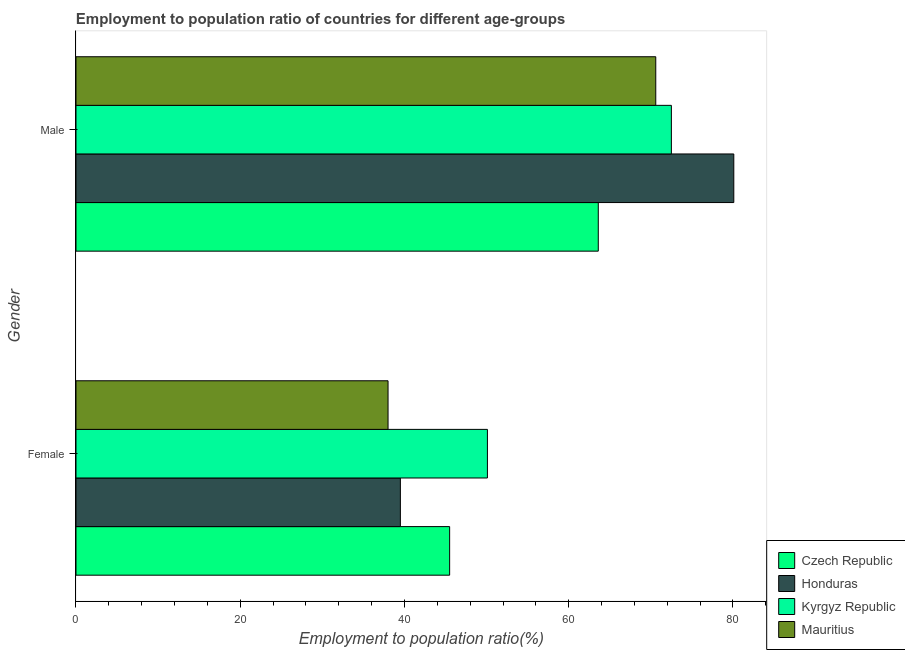Are the number of bars on each tick of the Y-axis equal?
Give a very brief answer. Yes. How many bars are there on the 2nd tick from the bottom?
Make the answer very short. 4. What is the label of the 1st group of bars from the top?
Keep it short and to the point. Male. What is the employment to population ratio(female) in Mauritius?
Ensure brevity in your answer.  38. Across all countries, what is the maximum employment to population ratio(female)?
Provide a short and direct response. 50.1. In which country was the employment to population ratio(male) maximum?
Keep it short and to the point. Honduras. In which country was the employment to population ratio(female) minimum?
Give a very brief answer. Mauritius. What is the total employment to population ratio(female) in the graph?
Ensure brevity in your answer.  173.1. What is the difference between the employment to population ratio(male) in Mauritius and that in Honduras?
Your response must be concise. -9.5. What is the difference between the employment to population ratio(female) in Czech Republic and the employment to population ratio(male) in Mauritius?
Your answer should be very brief. -25.1. What is the average employment to population ratio(female) per country?
Your answer should be compact. 43.27. What is the difference between the employment to population ratio(female) and employment to population ratio(male) in Czech Republic?
Provide a succinct answer. -18.1. In how many countries, is the employment to population ratio(male) greater than 68 %?
Keep it short and to the point. 3. What is the ratio of the employment to population ratio(female) in Czech Republic to that in Kyrgyz Republic?
Keep it short and to the point. 0.91. In how many countries, is the employment to population ratio(female) greater than the average employment to population ratio(female) taken over all countries?
Your answer should be very brief. 2. What does the 2nd bar from the top in Male represents?
Offer a terse response. Kyrgyz Republic. What does the 4th bar from the bottom in Female represents?
Your answer should be compact. Mauritius. How many countries are there in the graph?
Offer a very short reply. 4. What is the title of the graph?
Ensure brevity in your answer.  Employment to population ratio of countries for different age-groups. Does "Equatorial Guinea" appear as one of the legend labels in the graph?
Provide a short and direct response. No. What is the Employment to population ratio(%) in Czech Republic in Female?
Ensure brevity in your answer.  45.5. What is the Employment to population ratio(%) of Honduras in Female?
Provide a succinct answer. 39.5. What is the Employment to population ratio(%) in Kyrgyz Republic in Female?
Provide a short and direct response. 50.1. What is the Employment to population ratio(%) of Mauritius in Female?
Provide a short and direct response. 38. What is the Employment to population ratio(%) in Czech Republic in Male?
Provide a succinct answer. 63.6. What is the Employment to population ratio(%) of Honduras in Male?
Your answer should be compact. 80.1. What is the Employment to population ratio(%) in Kyrgyz Republic in Male?
Give a very brief answer. 72.5. What is the Employment to population ratio(%) in Mauritius in Male?
Keep it short and to the point. 70.6. Across all Gender, what is the maximum Employment to population ratio(%) of Czech Republic?
Keep it short and to the point. 63.6. Across all Gender, what is the maximum Employment to population ratio(%) of Honduras?
Provide a short and direct response. 80.1. Across all Gender, what is the maximum Employment to population ratio(%) in Kyrgyz Republic?
Offer a terse response. 72.5. Across all Gender, what is the maximum Employment to population ratio(%) in Mauritius?
Your response must be concise. 70.6. Across all Gender, what is the minimum Employment to population ratio(%) in Czech Republic?
Keep it short and to the point. 45.5. Across all Gender, what is the minimum Employment to population ratio(%) of Honduras?
Give a very brief answer. 39.5. Across all Gender, what is the minimum Employment to population ratio(%) of Kyrgyz Republic?
Your response must be concise. 50.1. What is the total Employment to population ratio(%) in Czech Republic in the graph?
Provide a short and direct response. 109.1. What is the total Employment to population ratio(%) of Honduras in the graph?
Make the answer very short. 119.6. What is the total Employment to population ratio(%) in Kyrgyz Republic in the graph?
Your response must be concise. 122.6. What is the total Employment to population ratio(%) of Mauritius in the graph?
Provide a short and direct response. 108.6. What is the difference between the Employment to population ratio(%) of Czech Republic in Female and that in Male?
Keep it short and to the point. -18.1. What is the difference between the Employment to population ratio(%) in Honduras in Female and that in Male?
Provide a succinct answer. -40.6. What is the difference between the Employment to population ratio(%) in Kyrgyz Republic in Female and that in Male?
Give a very brief answer. -22.4. What is the difference between the Employment to population ratio(%) of Mauritius in Female and that in Male?
Ensure brevity in your answer.  -32.6. What is the difference between the Employment to population ratio(%) in Czech Republic in Female and the Employment to population ratio(%) in Honduras in Male?
Provide a short and direct response. -34.6. What is the difference between the Employment to population ratio(%) of Czech Republic in Female and the Employment to population ratio(%) of Kyrgyz Republic in Male?
Ensure brevity in your answer.  -27. What is the difference between the Employment to population ratio(%) of Czech Republic in Female and the Employment to population ratio(%) of Mauritius in Male?
Provide a succinct answer. -25.1. What is the difference between the Employment to population ratio(%) in Honduras in Female and the Employment to population ratio(%) in Kyrgyz Republic in Male?
Your response must be concise. -33. What is the difference between the Employment to population ratio(%) in Honduras in Female and the Employment to population ratio(%) in Mauritius in Male?
Your answer should be compact. -31.1. What is the difference between the Employment to population ratio(%) in Kyrgyz Republic in Female and the Employment to population ratio(%) in Mauritius in Male?
Keep it short and to the point. -20.5. What is the average Employment to population ratio(%) of Czech Republic per Gender?
Ensure brevity in your answer.  54.55. What is the average Employment to population ratio(%) in Honduras per Gender?
Keep it short and to the point. 59.8. What is the average Employment to population ratio(%) of Kyrgyz Republic per Gender?
Provide a succinct answer. 61.3. What is the average Employment to population ratio(%) of Mauritius per Gender?
Offer a very short reply. 54.3. What is the difference between the Employment to population ratio(%) of Czech Republic and Employment to population ratio(%) of Kyrgyz Republic in Female?
Offer a terse response. -4.6. What is the difference between the Employment to population ratio(%) of Czech Republic and Employment to population ratio(%) of Mauritius in Female?
Offer a terse response. 7.5. What is the difference between the Employment to population ratio(%) of Honduras and Employment to population ratio(%) of Kyrgyz Republic in Female?
Provide a succinct answer. -10.6. What is the difference between the Employment to population ratio(%) of Kyrgyz Republic and Employment to population ratio(%) of Mauritius in Female?
Your answer should be compact. 12.1. What is the difference between the Employment to population ratio(%) in Czech Republic and Employment to population ratio(%) in Honduras in Male?
Offer a terse response. -16.5. What is the difference between the Employment to population ratio(%) of Czech Republic and Employment to population ratio(%) of Mauritius in Male?
Offer a terse response. -7. What is the difference between the Employment to population ratio(%) in Honduras and Employment to population ratio(%) in Kyrgyz Republic in Male?
Make the answer very short. 7.6. What is the difference between the Employment to population ratio(%) of Honduras and Employment to population ratio(%) of Mauritius in Male?
Keep it short and to the point. 9.5. What is the difference between the Employment to population ratio(%) in Kyrgyz Republic and Employment to population ratio(%) in Mauritius in Male?
Make the answer very short. 1.9. What is the ratio of the Employment to population ratio(%) of Czech Republic in Female to that in Male?
Offer a terse response. 0.72. What is the ratio of the Employment to population ratio(%) in Honduras in Female to that in Male?
Make the answer very short. 0.49. What is the ratio of the Employment to population ratio(%) of Kyrgyz Republic in Female to that in Male?
Give a very brief answer. 0.69. What is the ratio of the Employment to population ratio(%) of Mauritius in Female to that in Male?
Your response must be concise. 0.54. What is the difference between the highest and the second highest Employment to population ratio(%) in Honduras?
Offer a terse response. 40.6. What is the difference between the highest and the second highest Employment to population ratio(%) in Kyrgyz Republic?
Provide a succinct answer. 22.4. What is the difference between the highest and the second highest Employment to population ratio(%) in Mauritius?
Your response must be concise. 32.6. What is the difference between the highest and the lowest Employment to population ratio(%) in Honduras?
Your answer should be very brief. 40.6. What is the difference between the highest and the lowest Employment to population ratio(%) in Kyrgyz Republic?
Provide a succinct answer. 22.4. What is the difference between the highest and the lowest Employment to population ratio(%) of Mauritius?
Ensure brevity in your answer.  32.6. 